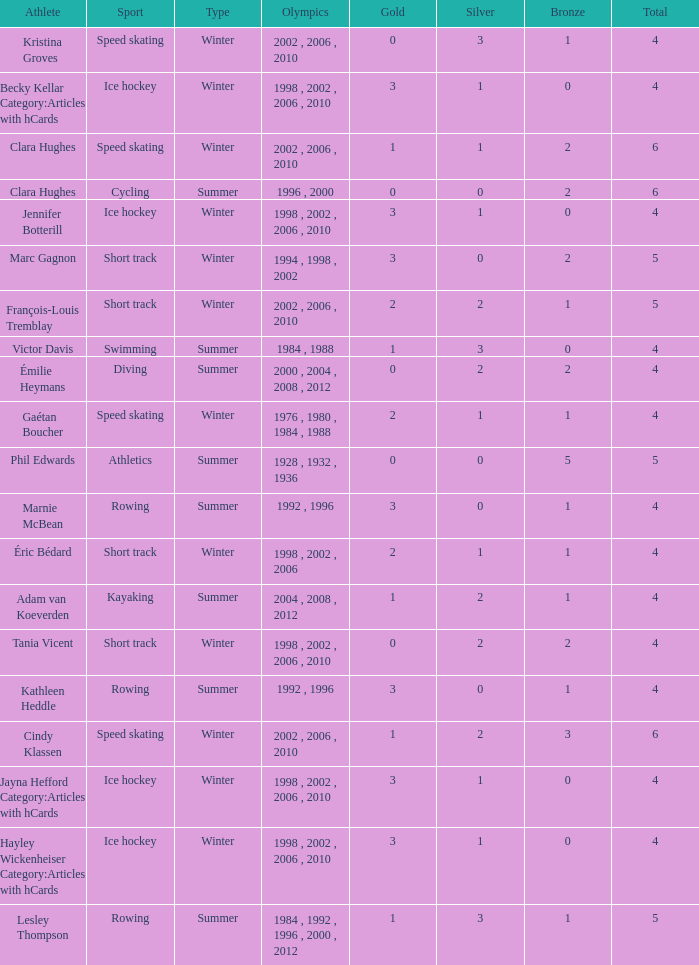What is the highest total medals winter athlete Clara Hughes has? 6.0. 